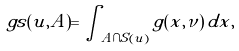<formula> <loc_0><loc_0><loc_500><loc_500>\ g s ( u , A ) = \int _ { A \cap S ( u ) } g ( x , \nu ) \, d x ,</formula> 